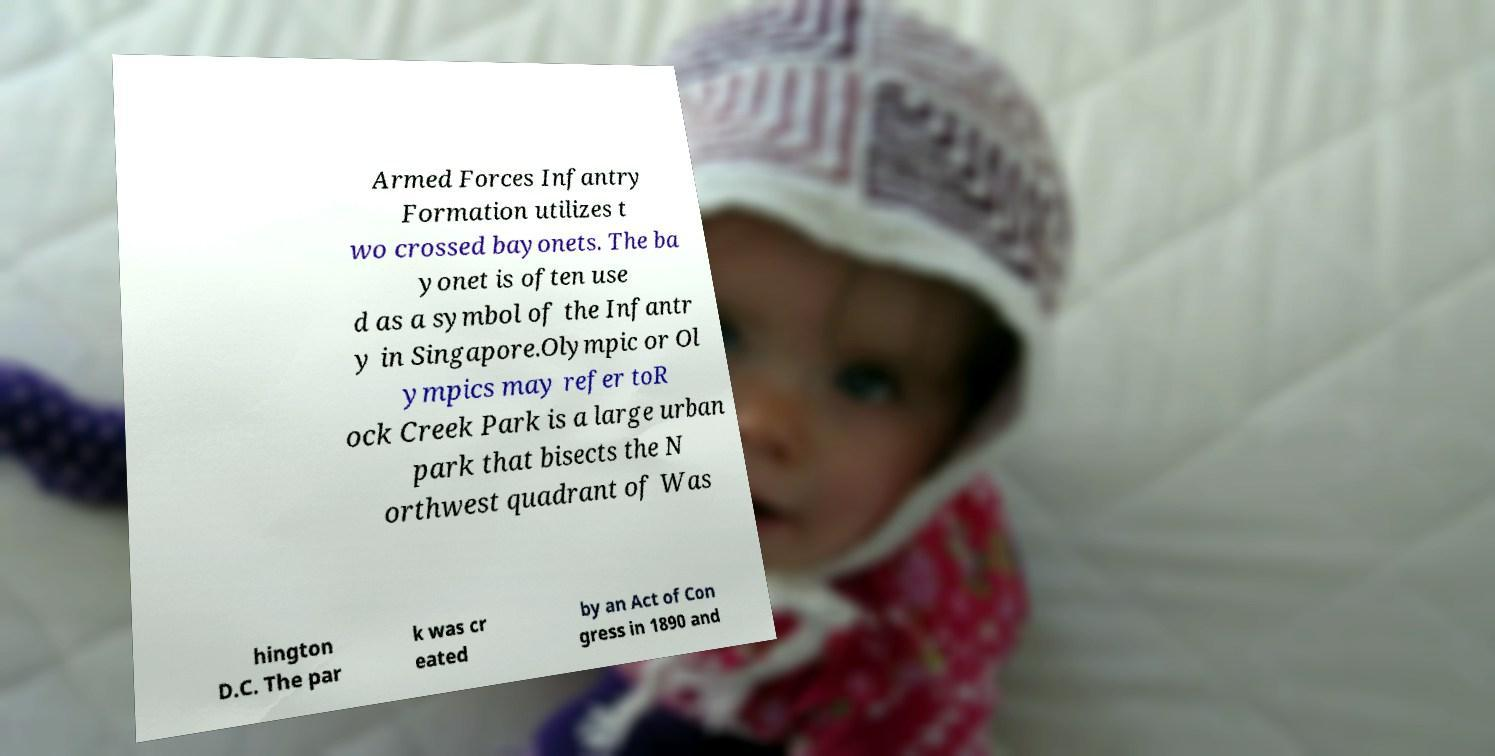Can you read and provide the text displayed in the image?This photo seems to have some interesting text. Can you extract and type it out for me? Armed Forces Infantry Formation utilizes t wo crossed bayonets. The ba yonet is often use d as a symbol of the Infantr y in Singapore.Olympic or Ol ympics may refer toR ock Creek Park is a large urban park that bisects the N orthwest quadrant of Was hington D.C. The par k was cr eated by an Act of Con gress in 1890 and 